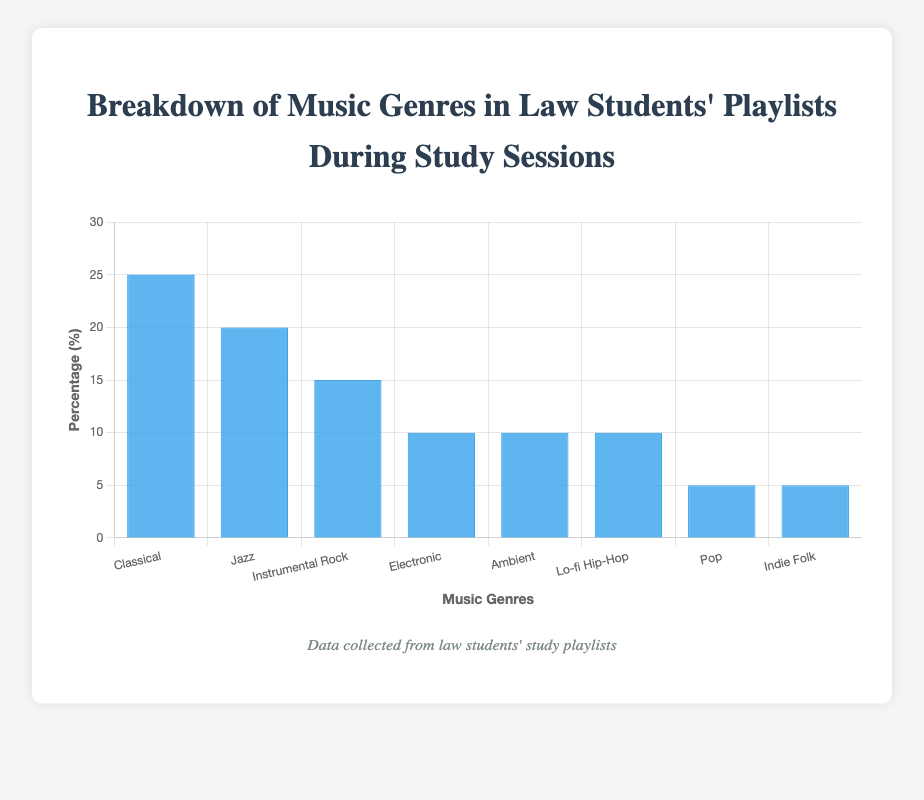What is the most popular genre among law students during study sessions? The bar representing Classical music is the tallest in the chart, indicating that it has the highest percentage. Therefore, Classical is the most popular genre among law students during study sessions.
Answer: Classical Which music genres have an equal percentage in law students' playlists? The chart shows three bars that have the same height, representing Electronic, Ambient, and Lo-fi Hip-Hop. These three genres all have a percentage of 10%.
Answer: Electronic, Ambient, Lo-fi Hip-Hop What is the total percentage of students who listen to Classical and Jazz music during their study sessions? The chart indicates that Classical music has a percentage of 25%, and Jazz has a percentage of 20%. Adding these together, 25% + 20% = 45%.
Answer: 45% How much greater is the percentage of law students who listen to Classical music compared to Pop music? The percentage of students listening to Classical music is 25%, and the percentage for Pop music is 5%. Subtracting these values, 25% - 5% = 20%.
Answer: 20% Which genre has the smallest percentage in law students' playlists? The bars for Pop and Indie Folk are the shortest, each representing a percentage of 5%. There are no genres with a smaller percentage than these two.
Answer: Pop, Indie Folk What is the average percentage of the top three music genres? The top three genres are Classical (25%), Jazz (20%), and Instrumental Rock (15%). Adding these percentages together and dividing by 3 gives (25 + 20 + 15) / 3 = 60 / 3 = 20%.
Answer: 20% How does the percentage of law students listening to Instrumental Rock compare to those listening to Lo-fi Hip-Hop? Instrumental Rock has a percentage of 15% and Lo-fi Hip-Hop has 10%. Therefore, Instrumental Rock has 5% more than Lo-fi Hip-Hop.
Answer: 5% What is the combined percentage of students who listen to Electronic, Ambient, and Lo-fi Hip-Hop music? Each of these genres has a percentage of 10%. Adding these together, 10% + 10% + 10% = 30%.
Answer: 30% How much lower is the percentage of Indie Folk compared to Jazz? The percentage for Indie Folk is 5%, and for Jazz, it is 20%. Subtracting these, 20% - 5% = 15%.
Answer: 15% What is the median percentage value of all the listed genres? The percentage values in ascending order are 5, 5, 10, 10, 10, 15, 20, 25. Since there are eight data points, the median will be the average of the fourth and fifth values. (10 + 10) / 2 = 10%.
Answer: 10% 